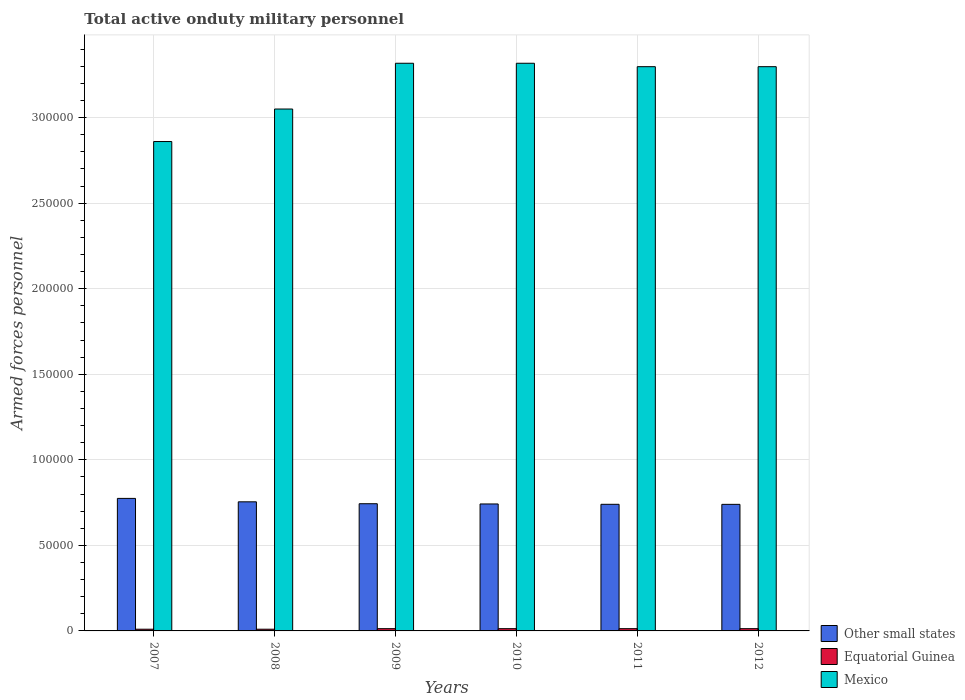How many different coloured bars are there?
Ensure brevity in your answer.  3. Are the number of bars on each tick of the X-axis equal?
Your response must be concise. Yes. What is the number of armed forces personnel in Mexico in 2011?
Your answer should be very brief. 3.30e+05. Across all years, what is the maximum number of armed forces personnel in Other small states?
Keep it short and to the point. 7.74e+04. Across all years, what is the minimum number of armed forces personnel in Mexico?
Your answer should be compact. 2.86e+05. In which year was the number of armed forces personnel in Mexico maximum?
Make the answer very short. 2009. In which year was the number of armed forces personnel in Equatorial Guinea minimum?
Offer a very short reply. 2007. What is the total number of armed forces personnel in Other small states in the graph?
Offer a very short reply. 4.49e+05. What is the difference between the number of armed forces personnel in Equatorial Guinea in 2008 and that in 2010?
Make the answer very short. -320. What is the difference between the number of armed forces personnel in Mexico in 2010 and the number of armed forces personnel in Equatorial Guinea in 2012?
Offer a very short reply. 3.30e+05. What is the average number of armed forces personnel in Equatorial Guinea per year?
Provide a succinct answer. 1213.33. In the year 2012, what is the difference between the number of armed forces personnel in Equatorial Guinea and number of armed forces personnel in Other small states?
Keep it short and to the point. -7.26e+04. In how many years, is the number of armed forces personnel in Equatorial Guinea greater than 80000?
Your answer should be compact. 0. What is the ratio of the number of armed forces personnel in Mexico in 2008 to that in 2009?
Give a very brief answer. 0.92. Is the difference between the number of armed forces personnel in Equatorial Guinea in 2011 and 2012 greater than the difference between the number of armed forces personnel in Other small states in 2011 and 2012?
Keep it short and to the point. No. What is the difference between the highest and the lowest number of armed forces personnel in Mexico?
Your answer should be compact. 4.58e+04. Is the sum of the number of armed forces personnel in Other small states in 2009 and 2010 greater than the maximum number of armed forces personnel in Equatorial Guinea across all years?
Provide a succinct answer. Yes. What does the 1st bar from the left in 2008 represents?
Keep it short and to the point. Other small states. What does the 2nd bar from the right in 2010 represents?
Keep it short and to the point. Equatorial Guinea. Is it the case that in every year, the sum of the number of armed forces personnel in Mexico and number of armed forces personnel in Other small states is greater than the number of armed forces personnel in Equatorial Guinea?
Keep it short and to the point. Yes. How many years are there in the graph?
Provide a short and direct response. 6. What is the difference between two consecutive major ticks on the Y-axis?
Your answer should be compact. 5.00e+04. Does the graph contain any zero values?
Provide a succinct answer. No. Does the graph contain grids?
Offer a very short reply. Yes. How many legend labels are there?
Give a very brief answer. 3. How are the legend labels stacked?
Make the answer very short. Vertical. What is the title of the graph?
Your response must be concise. Total active onduty military personnel. Does "Iraq" appear as one of the legend labels in the graph?
Offer a terse response. No. What is the label or title of the X-axis?
Provide a short and direct response. Years. What is the label or title of the Y-axis?
Your answer should be very brief. Armed forces personnel. What is the Armed forces personnel of Other small states in 2007?
Offer a very short reply. 7.74e+04. What is the Armed forces personnel in Equatorial Guinea in 2007?
Provide a short and direct response. 1000. What is the Armed forces personnel in Mexico in 2007?
Offer a terse response. 2.86e+05. What is the Armed forces personnel in Other small states in 2008?
Your answer should be compact. 7.54e+04. What is the Armed forces personnel in Equatorial Guinea in 2008?
Your answer should be compact. 1000. What is the Armed forces personnel in Mexico in 2008?
Make the answer very short. 3.05e+05. What is the Armed forces personnel of Other small states in 2009?
Your answer should be very brief. 7.43e+04. What is the Armed forces personnel in Equatorial Guinea in 2009?
Your answer should be compact. 1320. What is the Armed forces personnel in Mexico in 2009?
Keep it short and to the point. 3.32e+05. What is the Armed forces personnel of Other small states in 2010?
Ensure brevity in your answer.  7.42e+04. What is the Armed forces personnel of Equatorial Guinea in 2010?
Your response must be concise. 1320. What is the Armed forces personnel of Mexico in 2010?
Your answer should be very brief. 3.32e+05. What is the Armed forces personnel in Other small states in 2011?
Your response must be concise. 7.40e+04. What is the Armed forces personnel of Equatorial Guinea in 2011?
Provide a succinct answer. 1320. What is the Armed forces personnel in Mexico in 2011?
Make the answer very short. 3.30e+05. What is the Armed forces personnel of Other small states in 2012?
Your answer should be compact. 7.40e+04. What is the Armed forces personnel in Equatorial Guinea in 2012?
Ensure brevity in your answer.  1320. What is the Armed forces personnel in Mexico in 2012?
Give a very brief answer. 3.30e+05. Across all years, what is the maximum Armed forces personnel of Other small states?
Offer a terse response. 7.74e+04. Across all years, what is the maximum Armed forces personnel of Equatorial Guinea?
Your response must be concise. 1320. Across all years, what is the maximum Armed forces personnel in Mexico?
Make the answer very short. 3.32e+05. Across all years, what is the minimum Armed forces personnel in Other small states?
Provide a short and direct response. 7.40e+04. Across all years, what is the minimum Armed forces personnel of Mexico?
Your answer should be compact. 2.86e+05. What is the total Armed forces personnel of Other small states in the graph?
Your answer should be compact. 4.49e+05. What is the total Armed forces personnel of Equatorial Guinea in the graph?
Your answer should be very brief. 7280. What is the total Armed forces personnel of Mexico in the graph?
Offer a very short reply. 1.91e+06. What is the difference between the Armed forces personnel of Other small states in 2007 and that in 2008?
Ensure brevity in your answer.  2000. What is the difference between the Armed forces personnel of Mexico in 2007 and that in 2008?
Offer a terse response. -1.90e+04. What is the difference between the Armed forces personnel of Other small states in 2007 and that in 2009?
Offer a terse response. 3113. What is the difference between the Armed forces personnel in Equatorial Guinea in 2007 and that in 2009?
Give a very brief answer. -320. What is the difference between the Armed forces personnel of Mexico in 2007 and that in 2009?
Your response must be concise. -4.58e+04. What is the difference between the Armed forces personnel in Other small states in 2007 and that in 2010?
Make the answer very short. 3256. What is the difference between the Armed forces personnel in Equatorial Guinea in 2007 and that in 2010?
Provide a succinct answer. -320. What is the difference between the Armed forces personnel of Mexico in 2007 and that in 2010?
Offer a terse response. -4.58e+04. What is the difference between the Armed forces personnel in Other small states in 2007 and that in 2011?
Make the answer very short. 3450. What is the difference between the Armed forces personnel of Equatorial Guinea in 2007 and that in 2011?
Provide a short and direct response. -320. What is the difference between the Armed forces personnel of Mexico in 2007 and that in 2011?
Keep it short and to the point. -4.38e+04. What is the difference between the Armed forces personnel of Other small states in 2007 and that in 2012?
Your answer should be very brief. 3480. What is the difference between the Armed forces personnel of Equatorial Guinea in 2007 and that in 2012?
Your answer should be very brief. -320. What is the difference between the Armed forces personnel in Mexico in 2007 and that in 2012?
Provide a succinct answer. -4.38e+04. What is the difference between the Armed forces personnel in Other small states in 2008 and that in 2009?
Offer a terse response. 1113. What is the difference between the Armed forces personnel in Equatorial Guinea in 2008 and that in 2009?
Ensure brevity in your answer.  -320. What is the difference between the Armed forces personnel of Mexico in 2008 and that in 2009?
Provide a short and direct response. -2.68e+04. What is the difference between the Armed forces personnel of Other small states in 2008 and that in 2010?
Give a very brief answer. 1256. What is the difference between the Armed forces personnel in Equatorial Guinea in 2008 and that in 2010?
Your response must be concise. -320. What is the difference between the Armed forces personnel of Mexico in 2008 and that in 2010?
Your answer should be very brief. -2.68e+04. What is the difference between the Armed forces personnel in Other small states in 2008 and that in 2011?
Make the answer very short. 1450. What is the difference between the Armed forces personnel of Equatorial Guinea in 2008 and that in 2011?
Give a very brief answer. -320. What is the difference between the Armed forces personnel of Mexico in 2008 and that in 2011?
Offer a very short reply. -2.48e+04. What is the difference between the Armed forces personnel in Other small states in 2008 and that in 2012?
Offer a very short reply. 1480. What is the difference between the Armed forces personnel of Equatorial Guinea in 2008 and that in 2012?
Ensure brevity in your answer.  -320. What is the difference between the Armed forces personnel in Mexico in 2008 and that in 2012?
Ensure brevity in your answer.  -2.48e+04. What is the difference between the Armed forces personnel in Other small states in 2009 and that in 2010?
Give a very brief answer. 143. What is the difference between the Armed forces personnel of Other small states in 2009 and that in 2011?
Your answer should be compact. 337. What is the difference between the Armed forces personnel in Equatorial Guinea in 2009 and that in 2011?
Make the answer very short. 0. What is the difference between the Armed forces personnel of Other small states in 2009 and that in 2012?
Offer a very short reply. 367. What is the difference between the Armed forces personnel of Equatorial Guinea in 2009 and that in 2012?
Offer a terse response. 0. What is the difference between the Armed forces personnel in Other small states in 2010 and that in 2011?
Provide a succinct answer. 194. What is the difference between the Armed forces personnel of Mexico in 2010 and that in 2011?
Give a very brief answer. 2000. What is the difference between the Armed forces personnel in Other small states in 2010 and that in 2012?
Ensure brevity in your answer.  224. What is the difference between the Armed forces personnel of Equatorial Guinea in 2010 and that in 2012?
Offer a very short reply. 0. What is the difference between the Armed forces personnel of Equatorial Guinea in 2011 and that in 2012?
Your answer should be compact. 0. What is the difference between the Armed forces personnel of Other small states in 2007 and the Armed forces personnel of Equatorial Guinea in 2008?
Provide a short and direct response. 7.64e+04. What is the difference between the Armed forces personnel of Other small states in 2007 and the Armed forces personnel of Mexico in 2008?
Make the answer very short. -2.28e+05. What is the difference between the Armed forces personnel of Equatorial Guinea in 2007 and the Armed forces personnel of Mexico in 2008?
Make the answer very short. -3.04e+05. What is the difference between the Armed forces personnel of Other small states in 2007 and the Armed forces personnel of Equatorial Guinea in 2009?
Offer a terse response. 7.61e+04. What is the difference between the Armed forces personnel of Other small states in 2007 and the Armed forces personnel of Mexico in 2009?
Your answer should be very brief. -2.54e+05. What is the difference between the Armed forces personnel of Equatorial Guinea in 2007 and the Armed forces personnel of Mexico in 2009?
Your answer should be compact. -3.31e+05. What is the difference between the Armed forces personnel in Other small states in 2007 and the Armed forces personnel in Equatorial Guinea in 2010?
Offer a terse response. 7.61e+04. What is the difference between the Armed forces personnel in Other small states in 2007 and the Armed forces personnel in Mexico in 2010?
Your answer should be compact. -2.54e+05. What is the difference between the Armed forces personnel of Equatorial Guinea in 2007 and the Armed forces personnel of Mexico in 2010?
Keep it short and to the point. -3.31e+05. What is the difference between the Armed forces personnel in Other small states in 2007 and the Armed forces personnel in Equatorial Guinea in 2011?
Make the answer very short. 7.61e+04. What is the difference between the Armed forces personnel in Other small states in 2007 and the Armed forces personnel in Mexico in 2011?
Keep it short and to the point. -2.52e+05. What is the difference between the Armed forces personnel of Equatorial Guinea in 2007 and the Armed forces personnel of Mexico in 2011?
Ensure brevity in your answer.  -3.29e+05. What is the difference between the Armed forces personnel of Other small states in 2007 and the Armed forces personnel of Equatorial Guinea in 2012?
Keep it short and to the point. 7.61e+04. What is the difference between the Armed forces personnel of Other small states in 2007 and the Armed forces personnel of Mexico in 2012?
Make the answer very short. -2.52e+05. What is the difference between the Armed forces personnel of Equatorial Guinea in 2007 and the Armed forces personnel of Mexico in 2012?
Your answer should be very brief. -3.29e+05. What is the difference between the Armed forces personnel of Other small states in 2008 and the Armed forces personnel of Equatorial Guinea in 2009?
Your answer should be compact. 7.41e+04. What is the difference between the Armed forces personnel of Other small states in 2008 and the Armed forces personnel of Mexico in 2009?
Offer a very short reply. -2.56e+05. What is the difference between the Armed forces personnel of Equatorial Guinea in 2008 and the Armed forces personnel of Mexico in 2009?
Keep it short and to the point. -3.31e+05. What is the difference between the Armed forces personnel in Other small states in 2008 and the Armed forces personnel in Equatorial Guinea in 2010?
Ensure brevity in your answer.  7.41e+04. What is the difference between the Armed forces personnel in Other small states in 2008 and the Armed forces personnel in Mexico in 2010?
Provide a succinct answer. -2.56e+05. What is the difference between the Armed forces personnel of Equatorial Guinea in 2008 and the Armed forces personnel of Mexico in 2010?
Provide a succinct answer. -3.31e+05. What is the difference between the Armed forces personnel in Other small states in 2008 and the Armed forces personnel in Equatorial Guinea in 2011?
Ensure brevity in your answer.  7.41e+04. What is the difference between the Armed forces personnel of Other small states in 2008 and the Armed forces personnel of Mexico in 2011?
Give a very brief answer. -2.54e+05. What is the difference between the Armed forces personnel of Equatorial Guinea in 2008 and the Armed forces personnel of Mexico in 2011?
Your response must be concise. -3.29e+05. What is the difference between the Armed forces personnel in Other small states in 2008 and the Armed forces personnel in Equatorial Guinea in 2012?
Your answer should be compact. 7.41e+04. What is the difference between the Armed forces personnel of Other small states in 2008 and the Armed forces personnel of Mexico in 2012?
Your answer should be very brief. -2.54e+05. What is the difference between the Armed forces personnel in Equatorial Guinea in 2008 and the Armed forces personnel in Mexico in 2012?
Provide a succinct answer. -3.29e+05. What is the difference between the Armed forces personnel of Other small states in 2009 and the Armed forces personnel of Equatorial Guinea in 2010?
Your response must be concise. 7.30e+04. What is the difference between the Armed forces personnel of Other small states in 2009 and the Armed forces personnel of Mexico in 2010?
Provide a succinct answer. -2.57e+05. What is the difference between the Armed forces personnel of Equatorial Guinea in 2009 and the Armed forces personnel of Mexico in 2010?
Your response must be concise. -3.30e+05. What is the difference between the Armed forces personnel in Other small states in 2009 and the Armed forces personnel in Equatorial Guinea in 2011?
Ensure brevity in your answer.  7.30e+04. What is the difference between the Armed forces personnel of Other small states in 2009 and the Armed forces personnel of Mexico in 2011?
Provide a short and direct response. -2.55e+05. What is the difference between the Armed forces personnel in Equatorial Guinea in 2009 and the Armed forces personnel in Mexico in 2011?
Your response must be concise. -3.28e+05. What is the difference between the Armed forces personnel of Other small states in 2009 and the Armed forces personnel of Equatorial Guinea in 2012?
Keep it short and to the point. 7.30e+04. What is the difference between the Armed forces personnel in Other small states in 2009 and the Armed forces personnel in Mexico in 2012?
Give a very brief answer. -2.55e+05. What is the difference between the Armed forces personnel of Equatorial Guinea in 2009 and the Armed forces personnel of Mexico in 2012?
Your answer should be very brief. -3.28e+05. What is the difference between the Armed forces personnel in Other small states in 2010 and the Armed forces personnel in Equatorial Guinea in 2011?
Your response must be concise. 7.29e+04. What is the difference between the Armed forces personnel in Other small states in 2010 and the Armed forces personnel in Mexico in 2011?
Keep it short and to the point. -2.56e+05. What is the difference between the Armed forces personnel in Equatorial Guinea in 2010 and the Armed forces personnel in Mexico in 2011?
Offer a very short reply. -3.28e+05. What is the difference between the Armed forces personnel in Other small states in 2010 and the Armed forces personnel in Equatorial Guinea in 2012?
Your response must be concise. 7.29e+04. What is the difference between the Armed forces personnel of Other small states in 2010 and the Armed forces personnel of Mexico in 2012?
Your response must be concise. -2.56e+05. What is the difference between the Armed forces personnel in Equatorial Guinea in 2010 and the Armed forces personnel in Mexico in 2012?
Provide a short and direct response. -3.28e+05. What is the difference between the Armed forces personnel in Other small states in 2011 and the Armed forces personnel in Equatorial Guinea in 2012?
Your answer should be compact. 7.27e+04. What is the difference between the Armed forces personnel in Other small states in 2011 and the Armed forces personnel in Mexico in 2012?
Give a very brief answer. -2.56e+05. What is the difference between the Armed forces personnel in Equatorial Guinea in 2011 and the Armed forces personnel in Mexico in 2012?
Your response must be concise. -3.28e+05. What is the average Armed forces personnel of Other small states per year?
Your answer should be compact. 7.49e+04. What is the average Armed forces personnel of Equatorial Guinea per year?
Give a very brief answer. 1213.33. What is the average Armed forces personnel in Mexico per year?
Your answer should be very brief. 3.19e+05. In the year 2007, what is the difference between the Armed forces personnel of Other small states and Armed forces personnel of Equatorial Guinea?
Keep it short and to the point. 7.64e+04. In the year 2007, what is the difference between the Armed forces personnel of Other small states and Armed forces personnel of Mexico?
Provide a succinct answer. -2.09e+05. In the year 2007, what is the difference between the Armed forces personnel of Equatorial Guinea and Armed forces personnel of Mexico?
Give a very brief answer. -2.85e+05. In the year 2008, what is the difference between the Armed forces personnel in Other small states and Armed forces personnel in Equatorial Guinea?
Give a very brief answer. 7.44e+04. In the year 2008, what is the difference between the Armed forces personnel of Other small states and Armed forces personnel of Mexico?
Offer a terse response. -2.30e+05. In the year 2008, what is the difference between the Armed forces personnel in Equatorial Guinea and Armed forces personnel in Mexico?
Your answer should be very brief. -3.04e+05. In the year 2009, what is the difference between the Armed forces personnel of Other small states and Armed forces personnel of Equatorial Guinea?
Your response must be concise. 7.30e+04. In the year 2009, what is the difference between the Armed forces personnel in Other small states and Armed forces personnel in Mexico?
Provide a succinct answer. -2.57e+05. In the year 2009, what is the difference between the Armed forces personnel in Equatorial Guinea and Armed forces personnel in Mexico?
Offer a very short reply. -3.30e+05. In the year 2010, what is the difference between the Armed forces personnel of Other small states and Armed forces personnel of Equatorial Guinea?
Your answer should be compact. 7.29e+04. In the year 2010, what is the difference between the Armed forces personnel of Other small states and Armed forces personnel of Mexico?
Offer a very short reply. -2.58e+05. In the year 2010, what is the difference between the Armed forces personnel of Equatorial Guinea and Armed forces personnel of Mexico?
Give a very brief answer. -3.30e+05. In the year 2011, what is the difference between the Armed forces personnel of Other small states and Armed forces personnel of Equatorial Guinea?
Provide a succinct answer. 7.27e+04. In the year 2011, what is the difference between the Armed forces personnel in Other small states and Armed forces personnel in Mexico?
Your response must be concise. -2.56e+05. In the year 2011, what is the difference between the Armed forces personnel in Equatorial Guinea and Armed forces personnel in Mexico?
Offer a very short reply. -3.28e+05. In the year 2012, what is the difference between the Armed forces personnel of Other small states and Armed forces personnel of Equatorial Guinea?
Keep it short and to the point. 7.26e+04. In the year 2012, what is the difference between the Armed forces personnel in Other small states and Armed forces personnel in Mexico?
Ensure brevity in your answer.  -2.56e+05. In the year 2012, what is the difference between the Armed forces personnel of Equatorial Guinea and Armed forces personnel of Mexico?
Give a very brief answer. -3.28e+05. What is the ratio of the Armed forces personnel in Other small states in 2007 to that in 2008?
Offer a very short reply. 1.03. What is the ratio of the Armed forces personnel of Equatorial Guinea in 2007 to that in 2008?
Ensure brevity in your answer.  1. What is the ratio of the Armed forces personnel of Mexico in 2007 to that in 2008?
Give a very brief answer. 0.94. What is the ratio of the Armed forces personnel of Other small states in 2007 to that in 2009?
Your response must be concise. 1.04. What is the ratio of the Armed forces personnel in Equatorial Guinea in 2007 to that in 2009?
Provide a short and direct response. 0.76. What is the ratio of the Armed forces personnel of Mexico in 2007 to that in 2009?
Your response must be concise. 0.86. What is the ratio of the Armed forces personnel in Other small states in 2007 to that in 2010?
Provide a succinct answer. 1.04. What is the ratio of the Armed forces personnel in Equatorial Guinea in 2007 to that in 2010?
Provide a short and direct response. 0.76. What is the ratio of the Armed forces personnel of Mexico in 2007 to that in 2010?
Offer a very short reply. 0.86. What is the ratio of the Armed forces personnel in Other small states in 2007 to that in 2011?
Offer a very short reply. 1.05. What is the ratio of the Armed forces personnel in Equatorial Guinea in 2007 to that in 2011?
Keep it short and to the point. 0.76. What is the ratio of the Armed forces personnel in Mexico in 2007 to that in 2011?
Make the answer very short. 0.87. What is the ratio of the Armed forces personnel in Other small states in 2007 to that in 2012?
Make the answer very short. 1.05. What is the ratio of the Armed forces personnel of Equatorial Guinea in 2007 to that in 2012?
Provide a short and direct response. 0.76. What is the ratio of the Armed forces personnel in Mexico in 2007 to that in 2012?
Provide a short and direct response. 0.87. What is the ratio of the Armed forces personnel in Equatorial Guinea in 2008 to that in 2009?
Offer a terse response. 0.76. What is the ratio of the Armed forces personnel of Mexico in 2008 to that in 2009?
Ensure brevity in your answer.  0.92. What is the ratio of the Armed forces personnel of Other small states in 2008 to that in 2010?
Keep it short and to the point. 1.02. What is the ratio of the Armed forces personnel of Equatorial Guinea in 2008 to that in 2010?
Offer a terse response. 0.76. What is the ratio of the Armed forces personnel of Mexico in 2008 to that in 2010?
Offer a terse response. 0.92. What is the ratio of the Armed forces personnel of Other small states in 2008 to that in 2011?
Offer a terse response. 1.02. What is the ratio of the Armed forces personnel in Equatorial Guinea in 2008 to that in 2011?
Offer a very short reply. 0.76. What is the ratio of the Armed forces personnel of Mexico in 2008 to that in 2011?
Offer a very short reply. 0.92. What is the ratio of the Armed forces personnel of Equatorial Guinea in 2008 to that in 2012?
Offer a very short reply. 0.76. What is the ratio of the Armed forces personnel of Mexico in 2008 to that in 2012?
Make the answer very short. 0.92. What is the ratio of the Armed forces personnel in Mexico in 2009 to that in 2010?
Provide a short and direct response. 1. What is the ratio of the Armed forces personnel of Other small states in 2009 to that in 2011?
Keep it short and to the point. 1. What is the ratio of the Armed forces personnel in Equatorial Guinea in 2009 to that in 2011?
Offer a terse response. 1. What is the ratio of the Armed forces personnel of Equatorial Guinea in 2009 to that in 2012?
Ensure brevity in your answer.  1. What is the ratio of the Armed forces personnel of Mexico in 2009 to that in 2012?
Provide a short and direct response. 1.01. What is the ratio of the Armed forces personnel of Mexico in 2010 to that in 2012?
Ensure brevity in your answer.  1.01. What is the ratio of the Armed forces personnel in Equatorial Guinea in 2011 to that in 2012?
Give a very brief answer. 1. What is the difference between the highest and the second highest Armed forces personnel of Equatorial Guinea?
Provide a short and direct response. 0. What is the difference between the highest and the lowest Armed forces personnel of Other small states?
Provide a succinct answer. 3480. What is the difference between the highest and the lowest Armed forces personnel in Equatorial Guinea?
Keep it short and to the point. 320. What is the difference between the highest and the lowest Armed forces personnel of Mexico?
Offer a very short reply. 4.58e+04. 